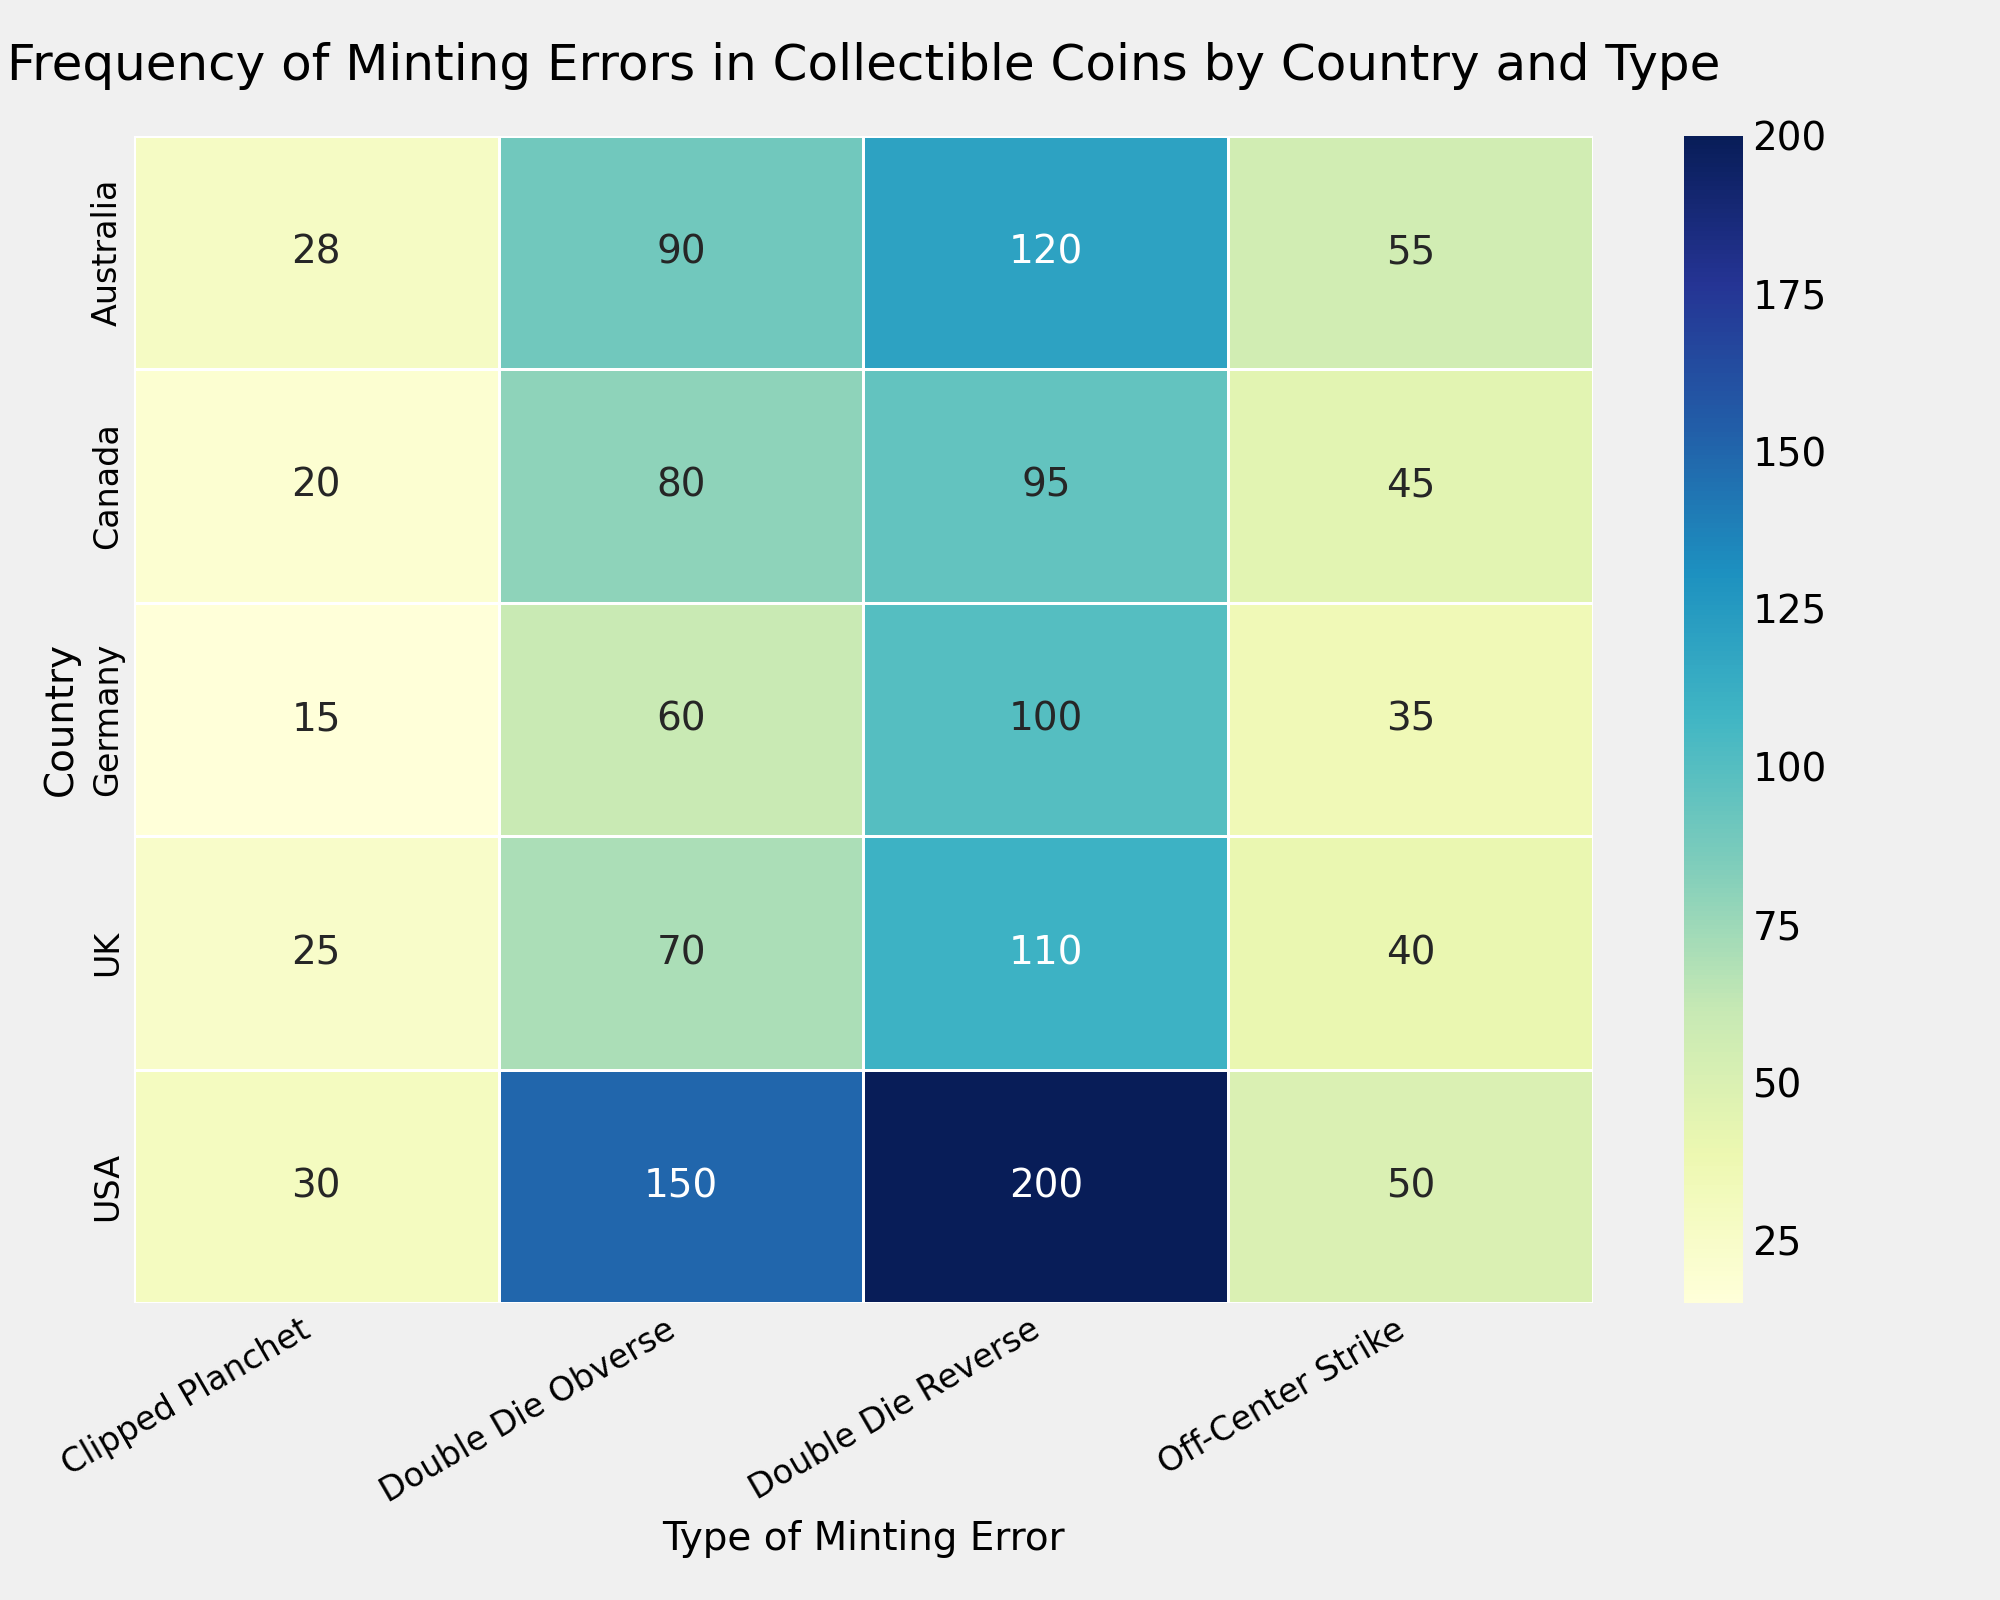Which country has the highest frequency of Double Die Reverse errors? Look at the heatmap and identify the country with the darkest shade of green in the column for Double Die Reverse. The darkest shade indicates the highest frequency.
Answer: USA Which country has the lowest total frequency of minting errors across all types? Sum the frequencies of all four types for each country. The country with the smallest total sum has the lowest frequency. For instance, for Germany: 60 + 100 + 35 + 15 = 210. Repeat for other countries to find the smallest sum.
Answer: Germany What is the average frequency of Clipped Planchet errors among all countries? Add the frequencies of Clipped Planchet errors for all countries and divide by the number of countries. (30 + 20 + 25 + 15 + 28) / 5 = 118 / 5 = 23.6
Answer: 23.6 For which type of minting error does Canada have the smallest frequency, and what is its value? Observe the frequencies for all four error types in the row for Canada. Identify the smallest number.
Answer: Clipped Planchet, 20 Compare the frequency of Double Die Obverse errors in the UK and Germany. Which one is higher and by how much? Look at the numbers for Double Die Obverse errors for both countries (UK: 70, Germany: 60). Subtract the smaller number from the larger number.
Answer: UK, 10 What is the sum of frequencies of Off-Center Strike errors for the USA and Australia? Locate the frequencies for Off-Center Strike for both countries (USA: 50, Australia: 55) and add them. 50 + 55 = 105
Answer: 105 Which type of minting error has the most variations in frequency across different countries? Compare the range (difference between the highest and lowest values) of each type of minting error across the countries. For example, Double Die Reverse ranges from 95 to 200. Repeat this for other types and identify the type with the largest range.
Answer: Double Die Reverse Is there any country where Clipped Planchet errors are more frequent than Off-Center Strike errors? Compare the two frequencies for Clipped Planchet and Off-Center Strike for each country. For example, for the USA Clipped Planchet (30) < Off-Center Strike (50). Repeat for other countries.
Answer: No 